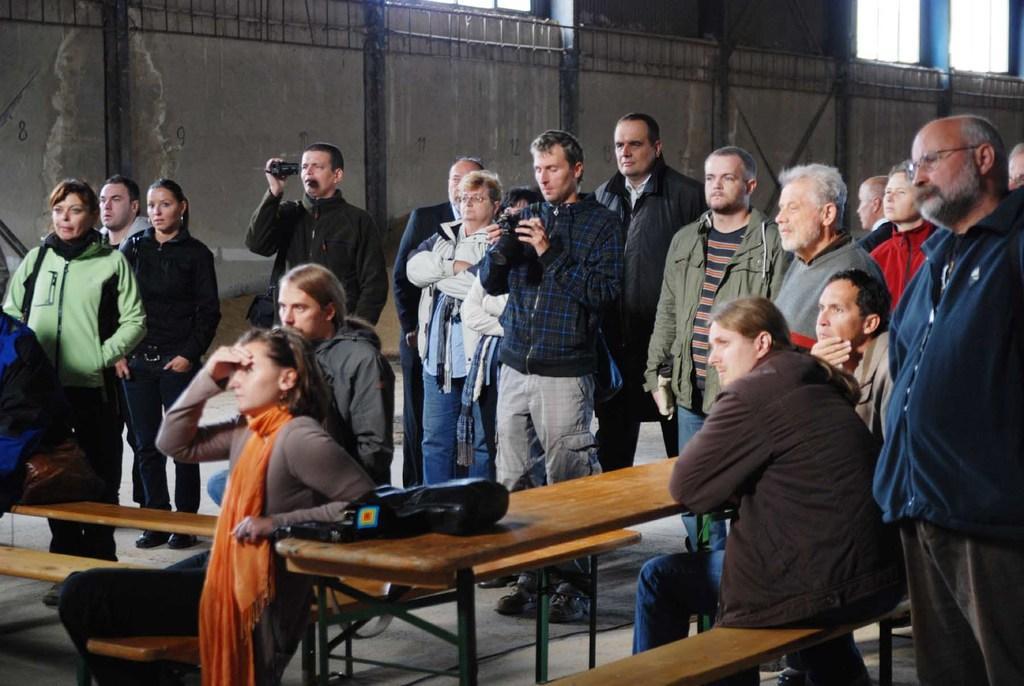Can you describe this image briefly? There are group of people standing and few people are sitting on a bench. This is a table where some object is placed on it. Among group of people there are two persons holding cameras. At background it looks like a building with windows. 